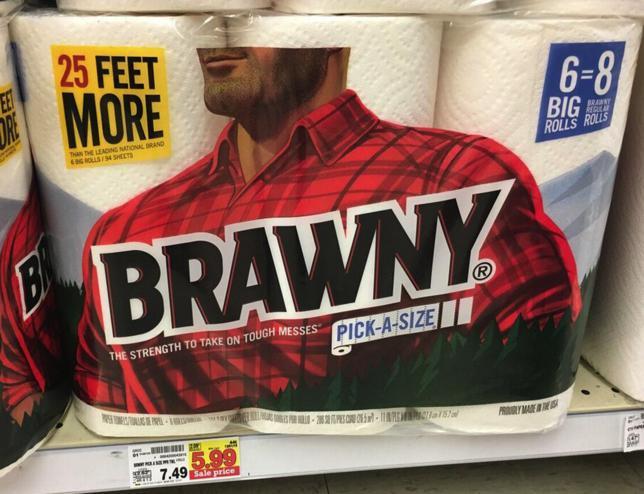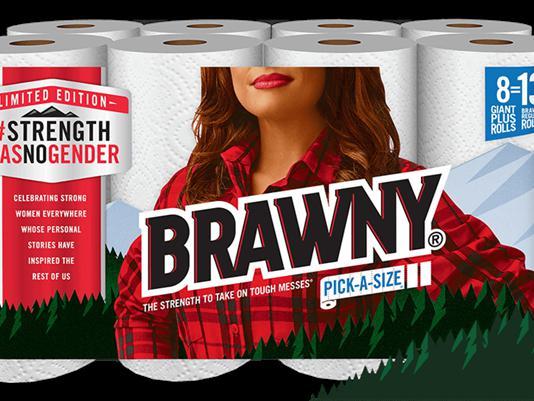The first image is the image on the left, the second image is the image on the right. Considering the images on both sides, is "At least one package is stacked on another in the image on the left." valid? Answer yes or no. No. The first image is the image on the left, the second image is the image on the right. Examine the images to the left and right. Is the description "A multi-pack of paper towel rolls shows a woman in a red plaid shirt on the package front." accurate? Answer yes or no. Yes. 